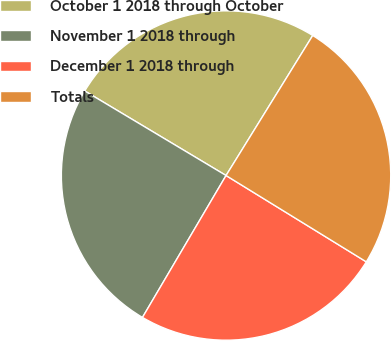<chart> <loc_0><loc_0><loc_500><loc_500><pie_chart><fcel>October 1 2018 through October<fcel>November 1 2018 through<fcel>December 1 2018 through<fcel>Totals<nl><fcel>25.24%<fcel>25.11%<fcel>24.69%<fcel>24.96%<nl></chart> 